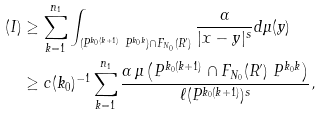<formula> <loc_0><loc_0><loc_500><loc_500>( I ) & \geq \sum _ { k = 1 } ^ { n _ { 1 } } \int _ { ( P ^ { k _ { 0 } ( k + 1 ) } \ P ^ { k _ { 0 } k } ) \cap F _ { N _ { 0 } } ( R ^ { \prime } ) } \frac { \alpha } { | x - y | ^ { s } } d \mu ( y ) \\ & \geq c ( k _ { 0 } ) ^ { - 1 } \sum _ { k = 1 } ^ { n _ { 1 } } \frac { \alpha \, \mu \left ( P ^ { k _ { 0 } ( k + 1 ) } \cap F _ { N _ { 0 } } ( R ^ { \prime } ) \ P ^ { k _ { 0 } k } \right ) } { \ell ( P ^ { k _ { 0 } ( k + 1 ) } ) ^ { s } } ,</formula> 